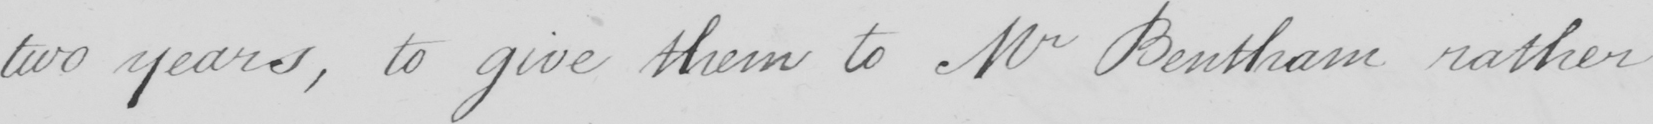What is written in this line of handwriting? two years , to give them to Mr Bentham rather 